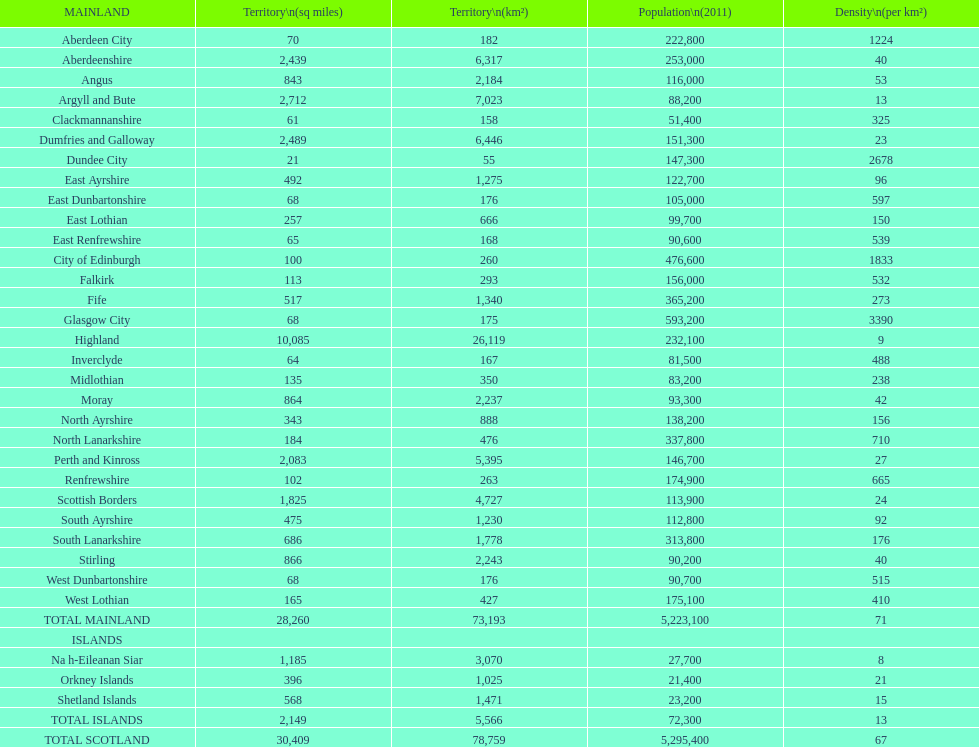What number of mainlands have populations under 100,000? 9. 